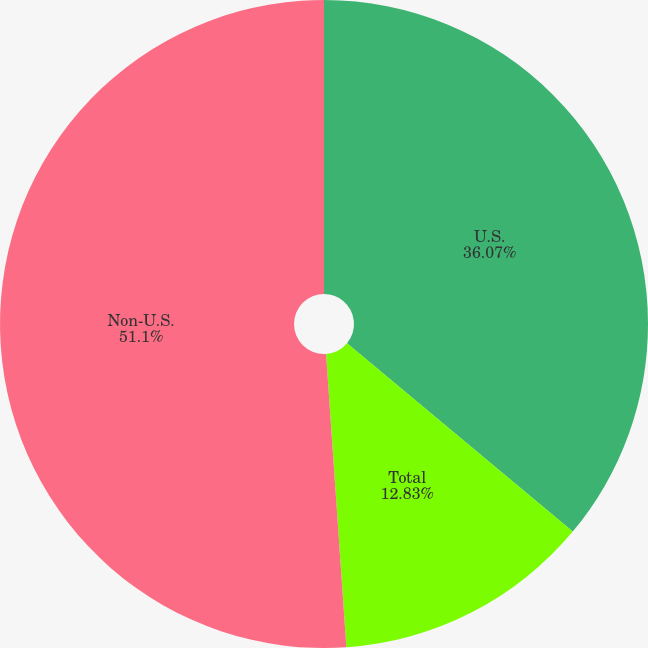Convert chart. <chart><loc_0><loc_0><loc_500><loc_500><pie_chart><fcel>U.S.<fcel>Total<fcel>Non-U.S.<nl><fcel>36.07%<fcel>12.83%<fcel>51.1%<nl></chart> 